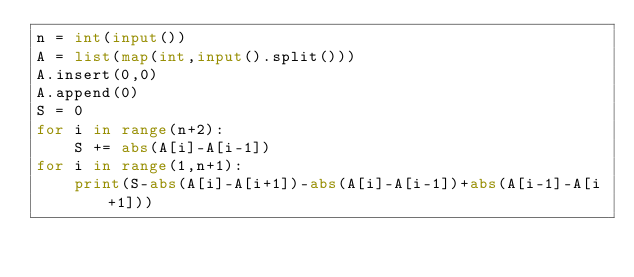Convert code to text. <code><loc_0><loc_0><loc_500><loc_500><_Python_>n = int(input())
A = list(map(int,input().split()))
A.insert(0,0)
A.append(0)
S = 0
for i in range(n+2):
    S += abs(A[i]-A[i-1])
for i in range(1,n+1):
    print(S-abs(A[i]-A[i+1])-abs(A[i]-A[i-1])+abs(A[i-1]-A[i+1]))</code> 